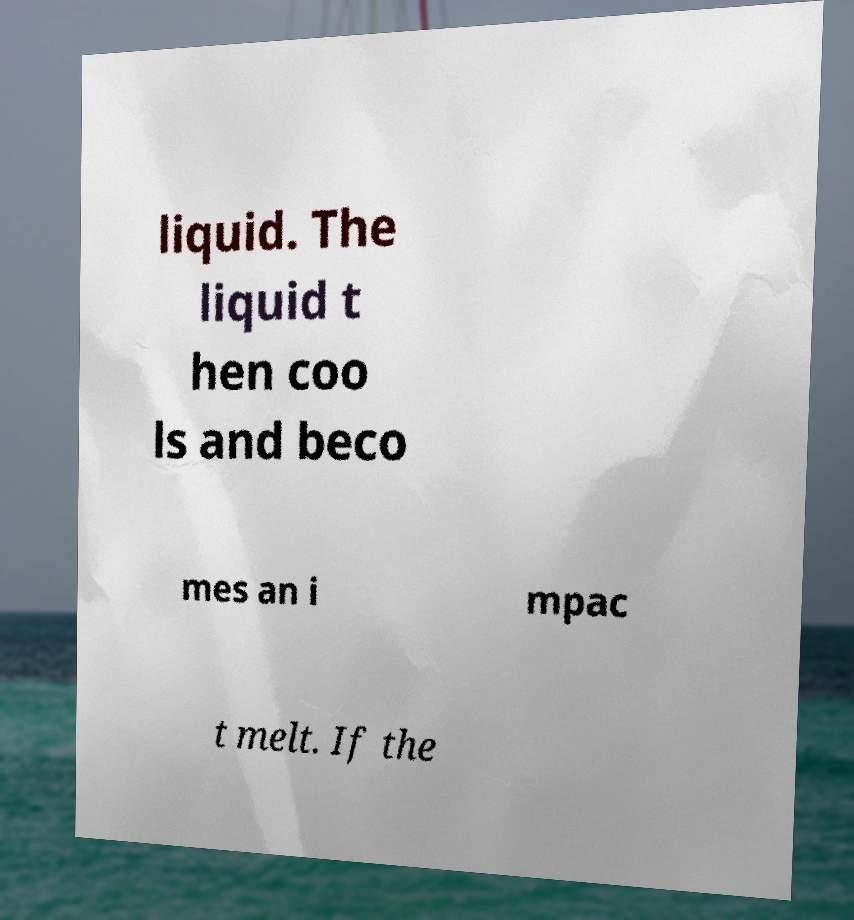What messages or text are displayed in this image? I need them in a readable, typed format. liquid. The liquid t hen coo ls and beco mes an i mpac t melt. If the 